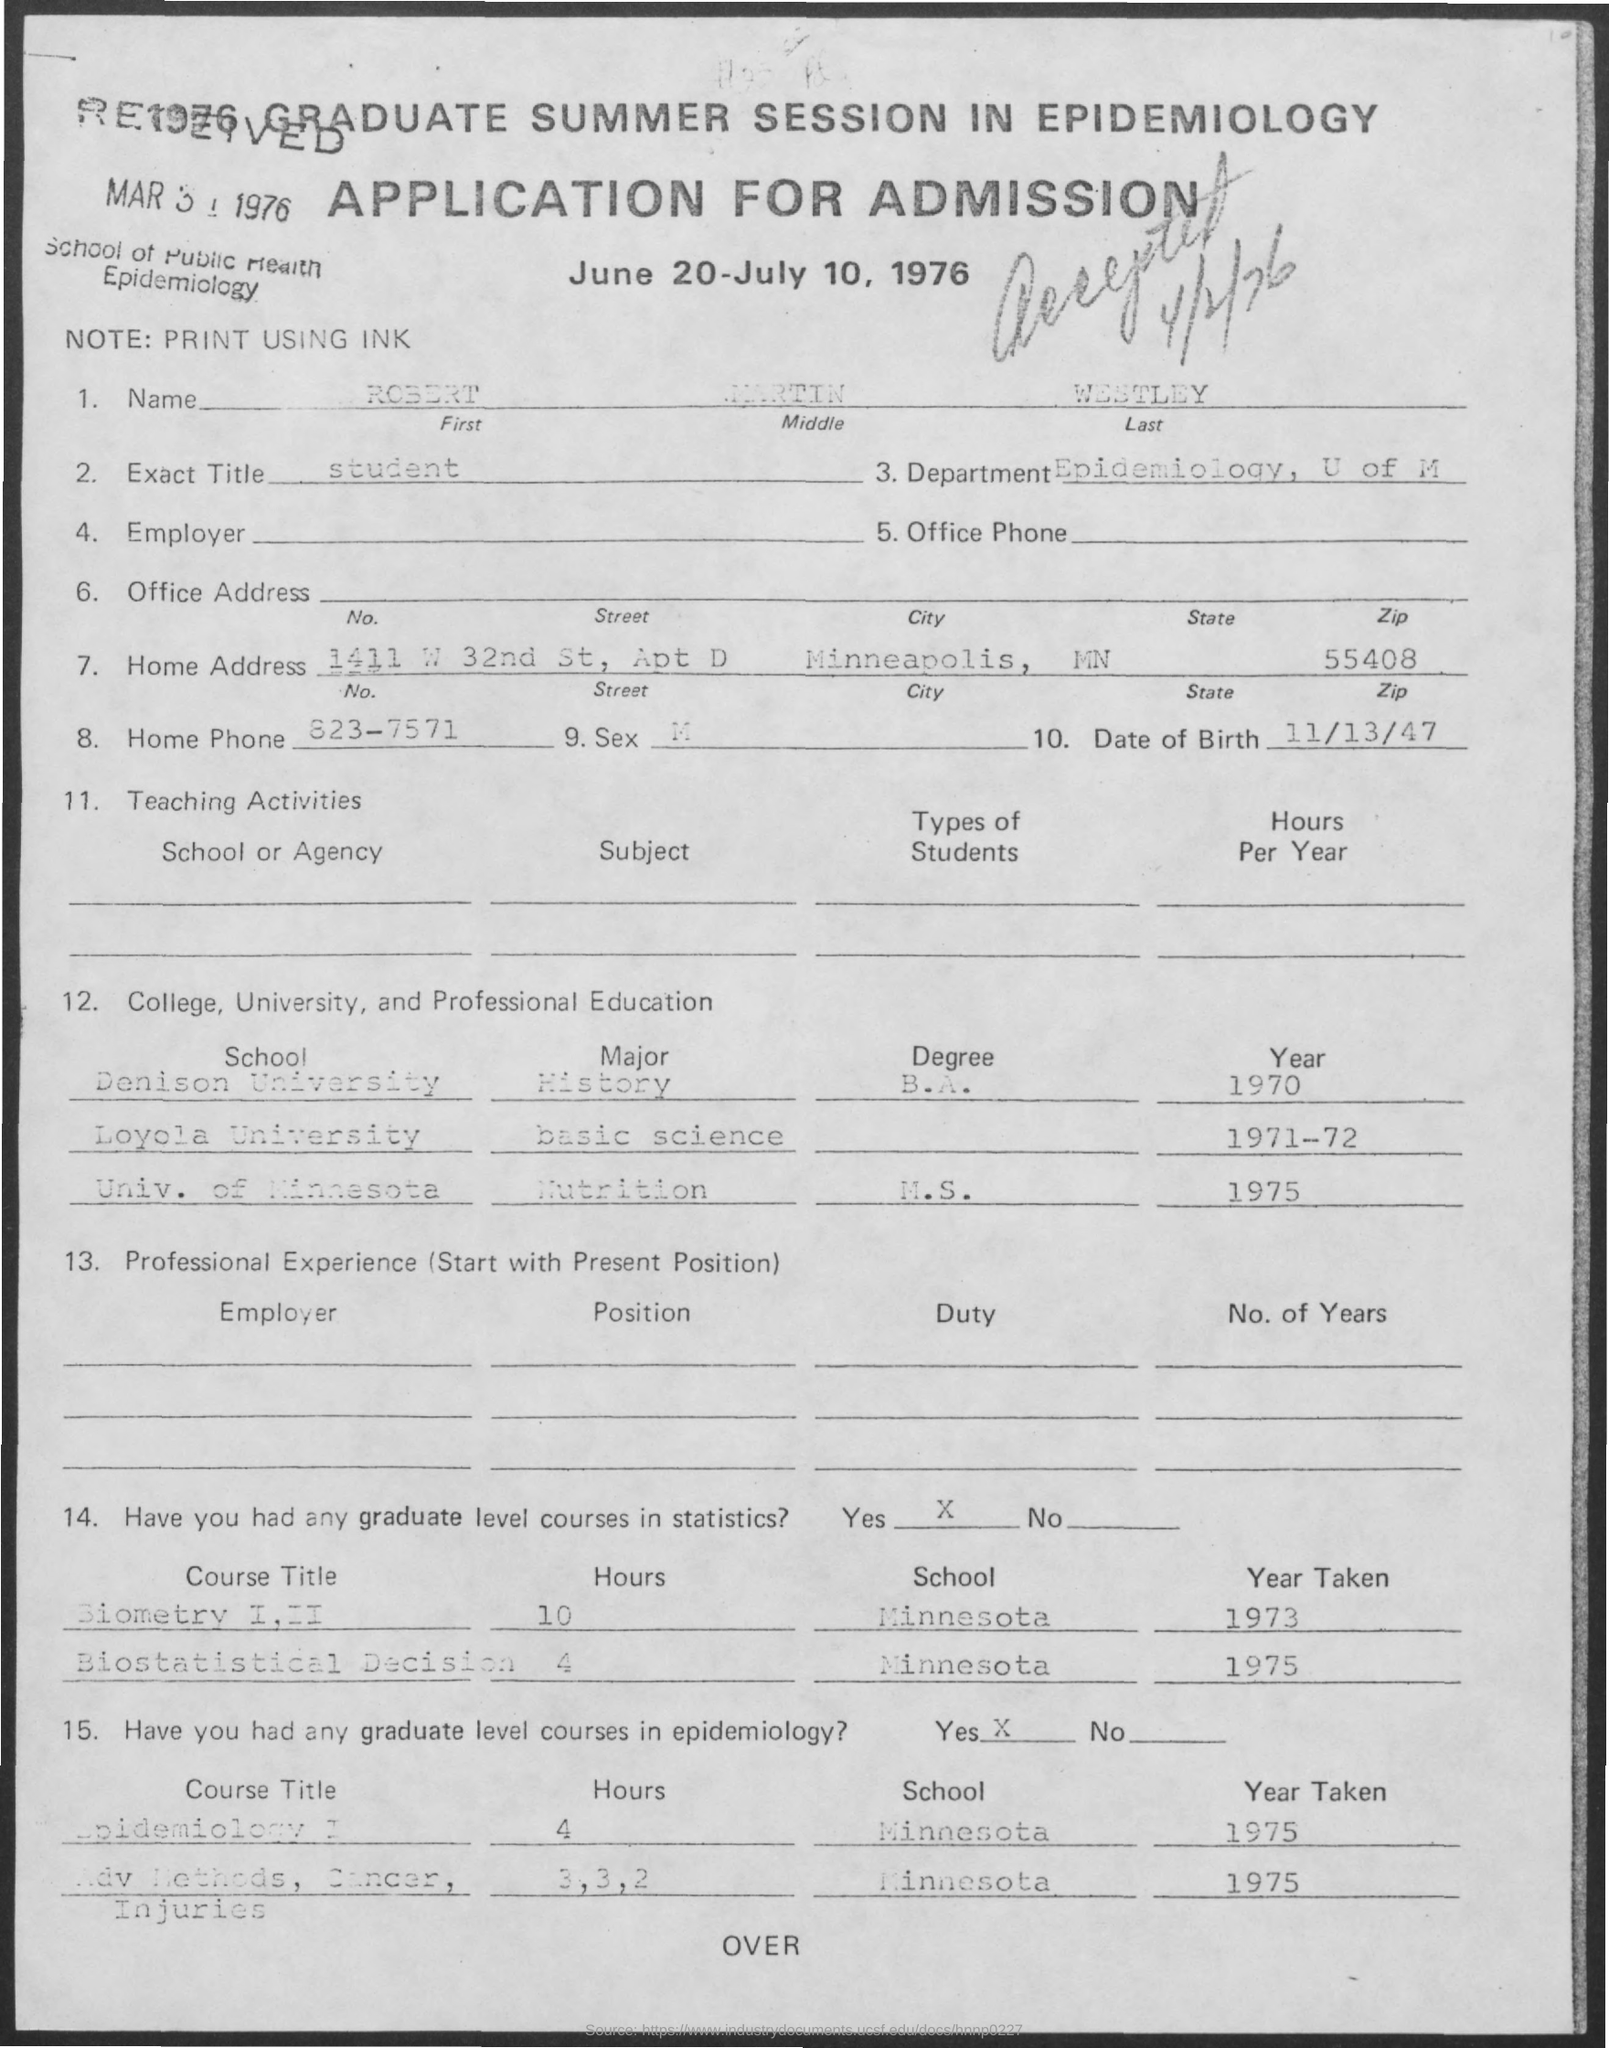Can you list any professional experience or positions held by the applicant? The document doesn’t list specific employers or positions under the section for professional experience; it indicates responsibilities with duties in epidemiology. 